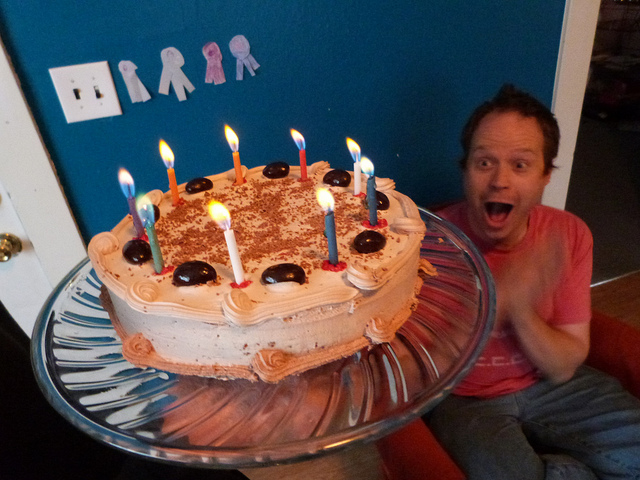Read all the text in this image. CCC 